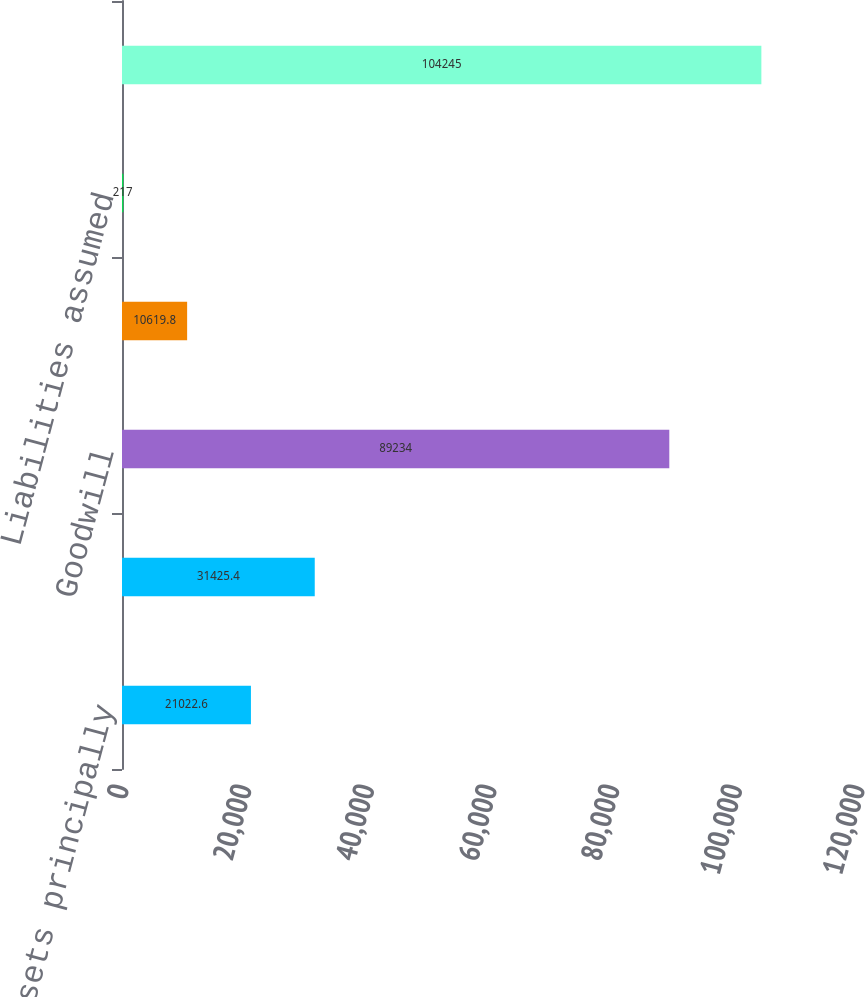<chart> <loc_0><loc_0><loc_500><loc_500><bar_chart><fcel>Tangible assets principally<fcel>Amortizable intangible assets<fcel>Goodwill<fcel>Noncontrolling interest net<fcel>Liabilities assumed<fcel>Aggregate purchase cost<nl><fcel>21022.6<fcel>31425.4<fcel>89234<fcel>10619.8<fcel>217<fcel>104245<nl></chart> 